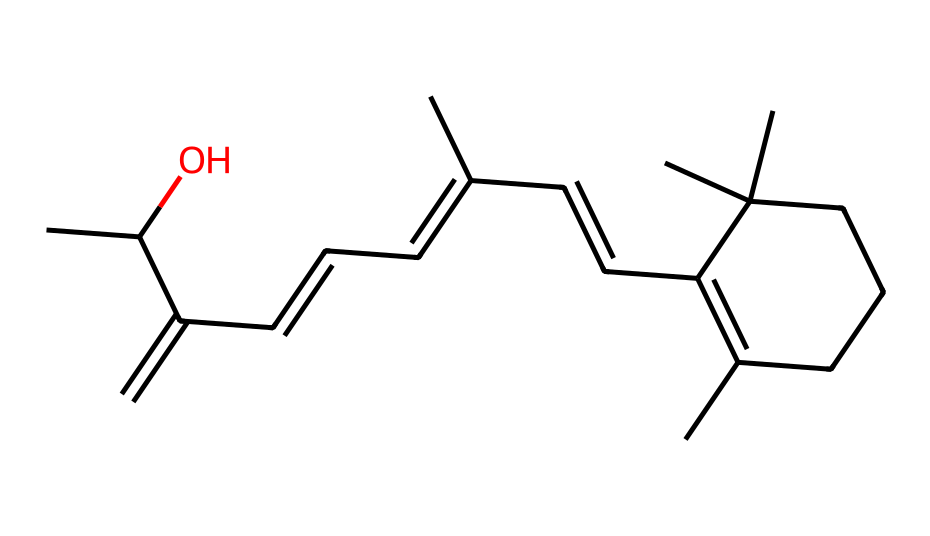How many carbon atoms are present in this chemical? To find the number of carbon atoms, we need to look closely at the SMILES representation. The SMILES string includes multiple "C" characters, which denote carbon atoms. Counting them gives us a total of 20 carbon atoms.
Answer: 20 What type of compound is this chemical? Based on the structure, this compound contains a long chain of carbon atoms and has the characteristic structural features of a retinoid, commonly known as vitamin A. Therefore, it can be classified as a retinoid.
Answer: retinoid What functional groups are present in this chemical? By analyzing the SMILES, we can identify that there is a hydroxyl (-OH) group indicated by "C(O)". This functional group contributes to the properties of the compound.
Answer: hydroxyl How many double bonds are present in this chemical structure? In the given SMILES structure, we can identify double bonds between carbon atoms represented by "=" symbols. Counting these, there are 5 double bonds present in the structure.
Answer: 5 Which part of this chemical structure is responsible for its anti-aging properties? Retinol's structure, particularly the presence of the conjugated double bonds and the hydroxyl group, allows it to penetrate the skin and influence cellular processes, which are responsible for its anti-aging effects.
Answer: conjugated double bonds How many rings are in the structure of this chemical? The SMILES indicates that while there are multiple connections between carbon atoms, if we look closely, we see there is one cyclic part that forms a ring, denoted by "C1" to "CCC1". Thus, there is one ring in the structure.
Answer: 1 